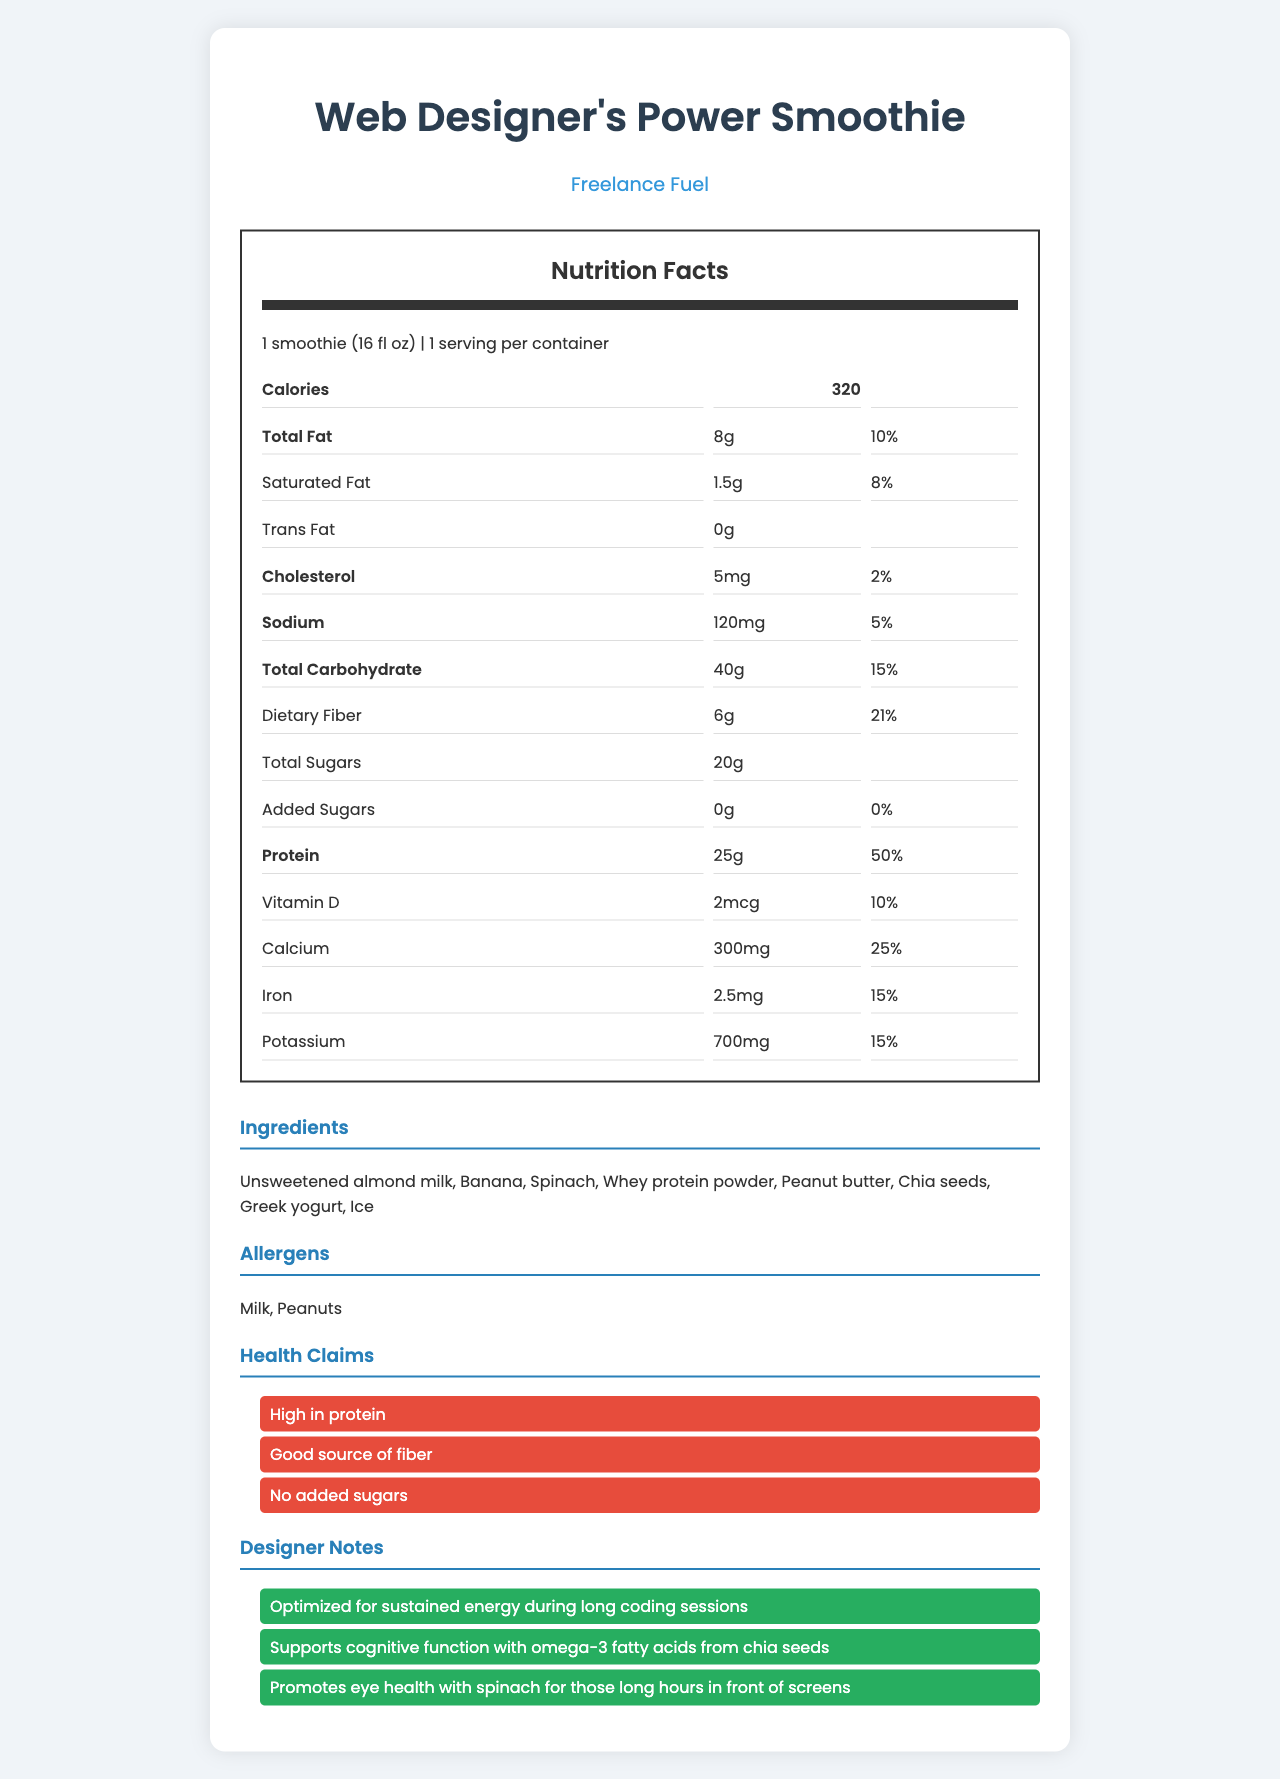what is the serving size? The serving size is provided at the beginning of the Nutrition Facts section, indicating that one serving is equivalent to 16 fl oz.
Answer: 1 smoothie (16 fl oz) how many calories does one serving contain? The calories content is listed in the Nutrition Facts section and is 320 calories per serving.
Answer: 320 which ingredient might be a concern for individuals with peanut allergies? The allergens section lists peanuts, and the ingredients section includes peanut butter.
Answer: Peanut butter how much protein is in one serving? The protein content is 25 grams per serving, as specified in the Nutrition Facts section.
Answer: 25 g what percentage of the daily value of calcium does one serving provide? In the Nutrition Facts section, the daily value for calcium is given as 25%.
Answer: 25% how much dietary fiber is in this smoothie? The Nutrition Facts section lists the dietary fiber amount as 6 grams.
Answer: 6 g how many servings are in the container? It is indicated at the beginning of the Nutrition Facts section that there is 1 serving per container.
Answer: 1 what is the brand name of this smoothie product? The brand name is displayed at the top of the document, right below the product name.
Answer: Freelance Fuel how much saturated fat does one serving contain? According to the Nutrition Facts section, one serving contains 1.5 grams of saturated fat.
Answer: 1.5 g how many ingredients are listed for this smoothie? The ingredients section lists eight ingredients.
Answer: 8 which of the following health claims is made on the label? A. Low in calories B. High in protein C. Contains added sugars The health claims section includes "High in protein" but does not mention being low in calories or containing added sugars.
Answer: B. High in protein which allergen is NOT part of this smoothie? A. Milk B. Peanuts C. Soy The allergens listed are milk and peanuts; soy is not mentioned.
Answer: C. Soy does this smoothie contain any added sugars? The Nutrition Facts section specifically lists 0 grams of added sugars.
Answer: No is this smoothie suitable for vegetarians? The document does not specify the origin of whey protein powder and other ingredients, making it unclear if the smoothie is suitable for vegetarians.
Answer: Cannot be determined summarize the main features of the Web Designer's Power Smoothie. This summary captures the essential nutrition information, ingredients, and health claims provided in the document, along with the overall health benefits explained in the designer notes.
Answer: A health-conscious smoothie with 320 calories per serving, high in protein (25 g), and a good source of fiber (6 g). It contains unsweetened almond milk, banana, spinach, whey protein powder, peanut butter, chia seeds, Greek yogurt, and ice. The product has several health claims including "High in protein", "Good source of fiber", and "No added sugars". 